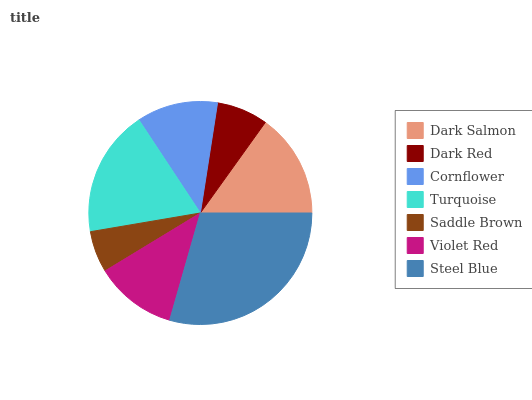Is Saddle Brown the minimum?
Answer yes or no. Yes. Is Steel Blue the maximum?
Answer yes or no. Yes. Is Dark Red the minimum?
Answer yes or no. No. Is Dark Red the maximum?
Answer yes or no. No. Is Dark Salmon greater than Dark Red?
Answer yes or no. Yes. Is Dark Red less than Dark Salmon?
Answer yes or no. Yes. Is Dark Red greater than Dark Salmon?
Answer yes or no. No. Is Dark Salmon less than Dark Red?
Answer yes or no. No. Is Violet Red the high median?
Answer yes or no. Yes. Is Violet Red the low median?
Answer yes or no. Yes. Is Dark Red the high median?
Answer yes or no. No. Is Dark Red the low median?
Answer yes or no. No. 